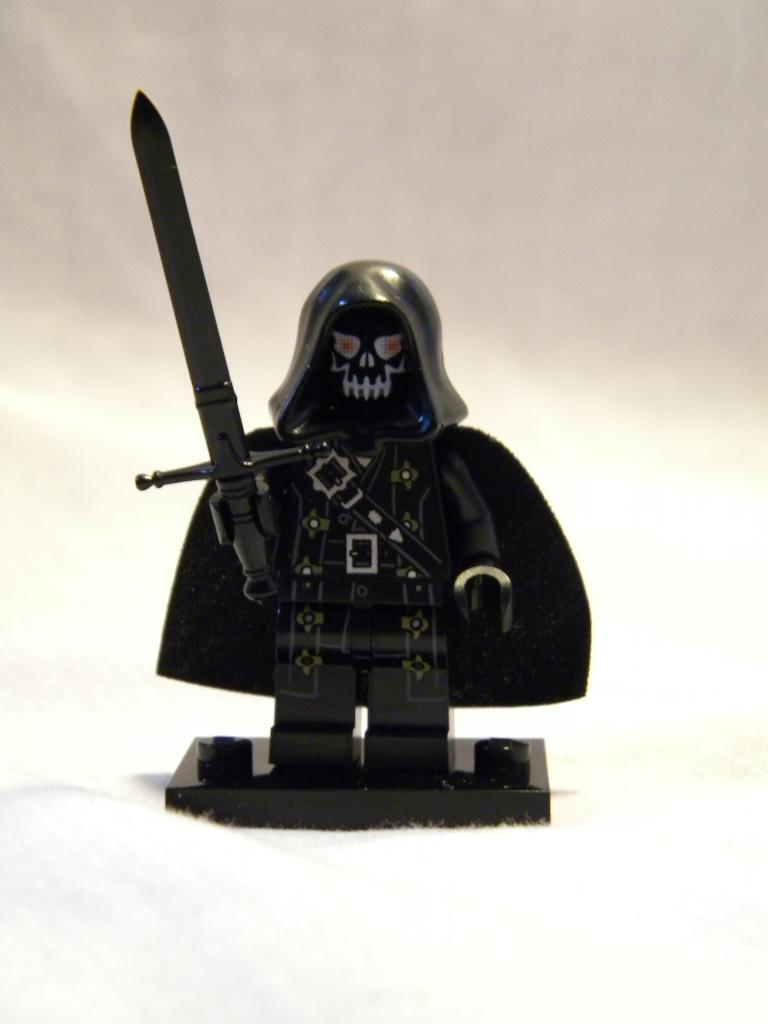What object can be seen in the image? There is a toy in the image. What is the color of the surface the toy is placed on? The toy is on a white surface. How would you describe the background of the image? The background of the image is white and grey. How many aunts are sitting on the chairs in the image? There are no aunts or chairs present in the image. What is the hope for the future of the toy in the image? The image does not provide any information about the future of the toy or any hopes related to it. 